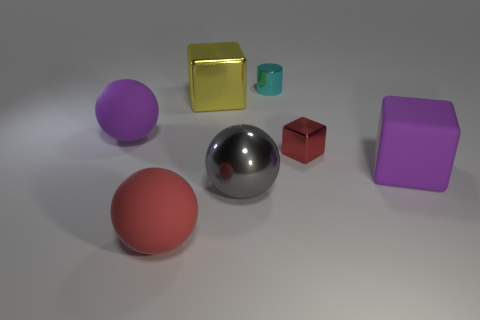What number of yellow metal cubes have the same size as the purple matte sphere?
Provide a short and direct response. 1. What is the big purple ball made of?
Make the answer very short. Rubber. Is the number of tiny gray matte objects greater than the number of large red matte spheres?
Provide a succinct answer. No. Do the big gray object and the small cyan object have the same shape?
Your answer should be compact. No. Is there anything else that is the same shape as the cyan object?
Your answer should be compact. No. There is a big block that is left of the gray metal thing; is its color the same as the tiny thing that is behind the small red block?
Give a very brief answer. No. Is the number of small metallic cylinders on the left side of the red rubber object less than the number of large red rubber objects that are left of the gray metallic object?
Keep it short and to the point. Yes. The large rubber thing that is right of the gray metal thing has what shape?
Make the answer very short. Cube. What is the material of the large ball that is the same color as the small cube?
Provide a succinct answer. Rubber. What number of other things are there of the same material as the large gray object
Offer a terse response. 3. 